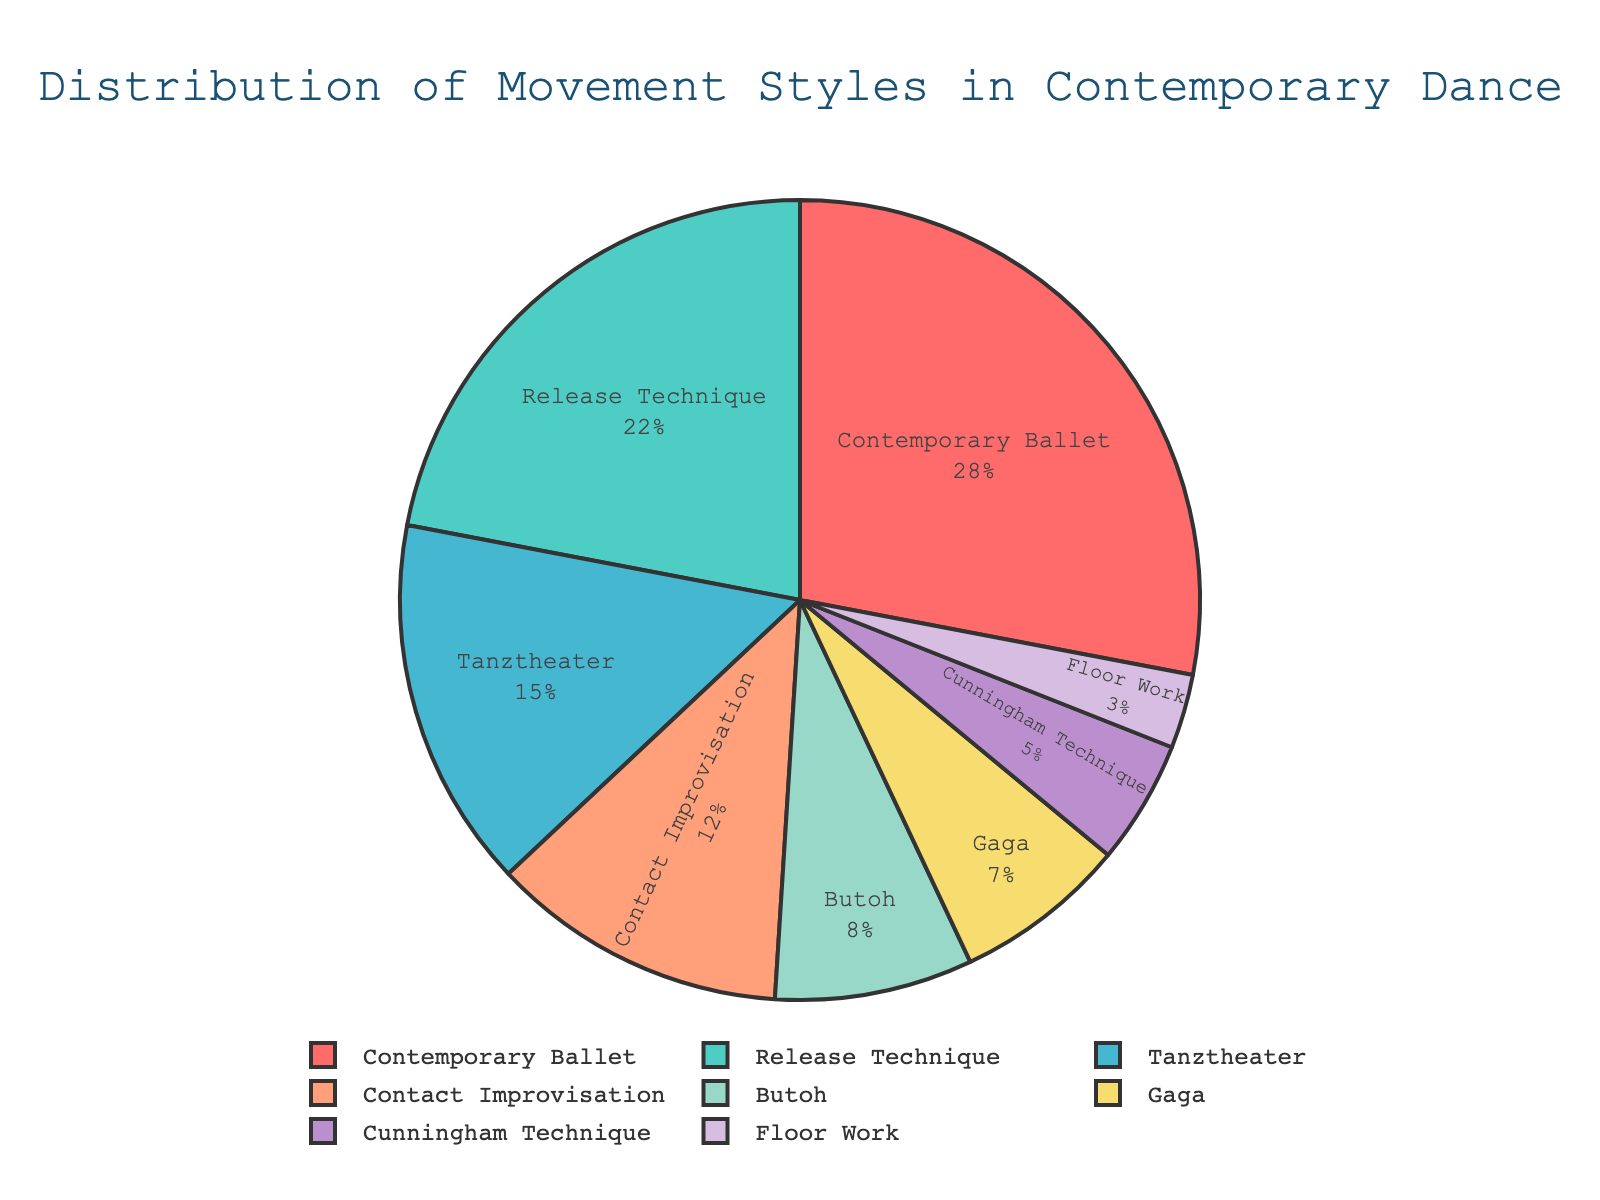What is the percentage of Contemporary Ballet? The pie chart indicates the distribution percentages for various movement styles. The section labeled "Contemporary Ballet" shows 28%.
Answer: 28% How does the percentage of Butoh compare to Cunningham Technique? The segment for Butoh represents 8% and Cunningham Technique represents 5%. Thus, Butoh has a higher percentage by 3%.
Answer: Butoh is 3% higher What is the sum of the percentages for Release Technique and Tanztheater? Release Technique is 22% and Tanztheater is 15%. Adding these two gives 22 + 15 = 37%.
Answer: 37% Which movement style has the lowest percentage? The smallest segment appears for Floor Work, which is marked at 3%.
Answer: Floor Work Are there more performances based on Contact Improvisation or Gaga? Contact Improvisation corresponds to 12%, while Gaga corresponds to 7%. Contact Improvisation has a higher percentage.
Answer: Contact Improvisation What is the total percentage for the three smallest categories? Floor Work is 3%, Cunningham Technique is 5%, and Gaga is 7%. Summing these: 3 + 5 + 7 = 15%.
Answer: 15% Which style has the second-largest share? After Contemporary Ballet (28%), the next largest segment is Release Technique at 22%.
Answer: Release Technique How much larger is the percentage of Contemporary Ballet compared to Release Technique? Contemporary Ballet is 28% and Release Technique is 22%. The difference is 28 - 22 = 6%.
Answer: 6% What is the combined percentage of Contemporary Ballet, Tanztheater, and Butoh? Contemporary Ballet is 28%, Tanztheater is 15%, and Butoh is 8%. Summing these: 28 + 15 + 8 = 51%.
Answer: 51% Which movement styles together make up more than half of the total distribution? Contemporary Ballet (28%) and Release Technique (22%) together sum up to 50%. Adding any other style, like Tanztheater (15%), would surpass the 50% threshold.
Answer: Contemporary Ballet, Release Technique, and Tanztheater 